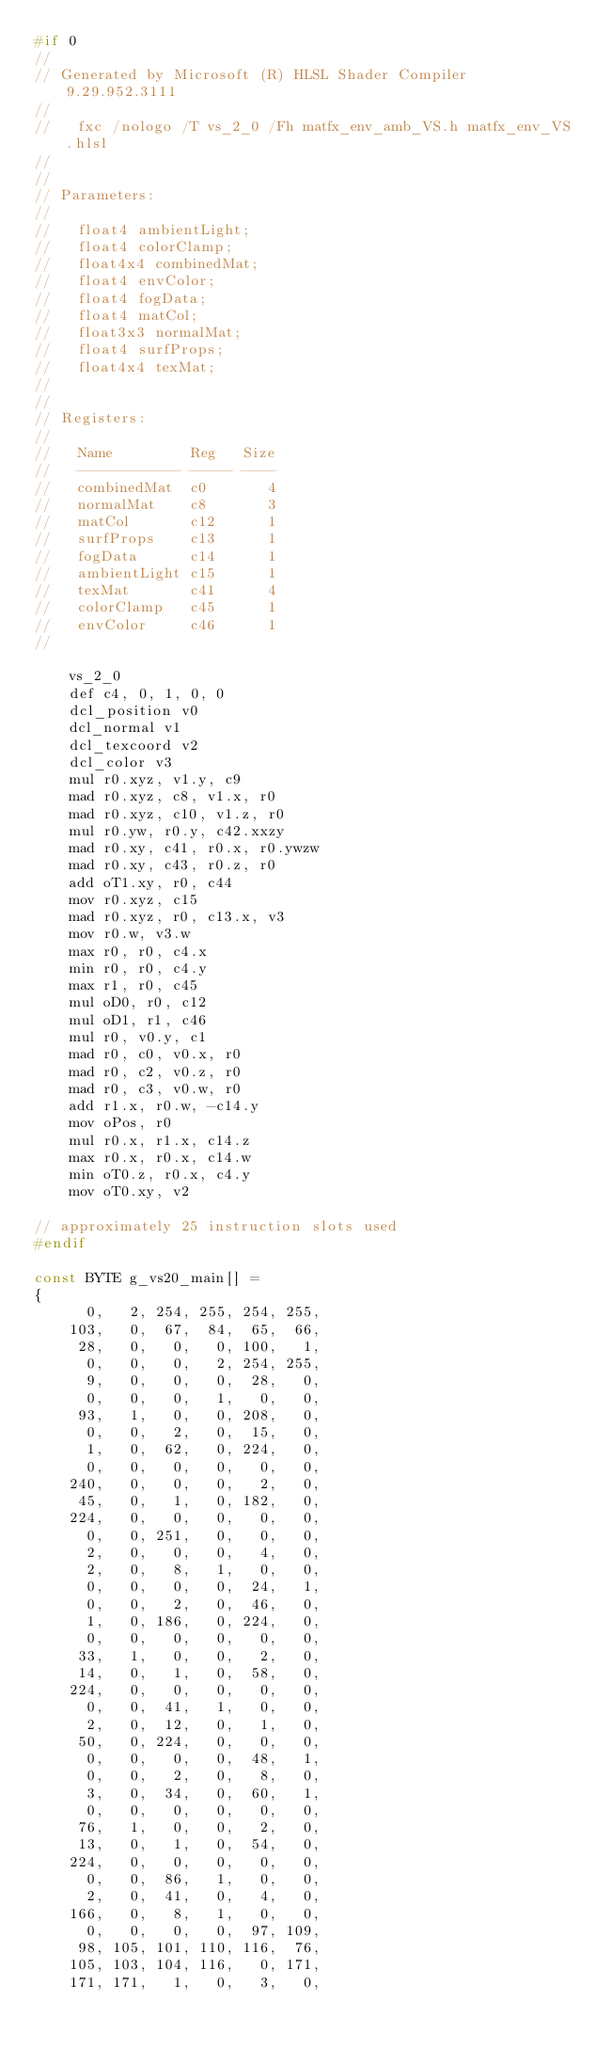Convert code to text. <code><loc_0><loc_0><loc_500><loc_500><_C_>#if 0
//
// Generated by Microsoft (R) HLSL Shader Compiler 9.29.952.3111
//
//   fxc /nologo /T vs_2_0 /Fh matfx_env_amb_VS.h matfx_env_VS.hlsl
//
//
// Parameters:
//
//   float4 ambientLight;
//   float4 colorClamp;
//   float4x4 combinedMat;
//   float4 envColor;
//   float4 fogData;
//   float4 matCol;
//   float3x3 normalMat;
//   float4 surfProps;
//   float4x4 texMat;
//
//
// Registers:
//
//   Name         Reg   Size
//   ------------ ----- ----
//   combinedMat  c0       4
//   normalMat    c8       3
//   matCol       c12      1
//   surfProps    c13      1
//   fogData      c14      1
//   ambientLight c15      1
//   texMat       c41      4
//   colorClamp   c45      1
//   envColor     c46      1
//

    vs_2_0
    def c4, 0, 1, 0, 0
    dcl_position v0
    dcl_normal v1
    dcl_texcoord v2
    dcl_color v3
    mul r0.xyz, v1.y, c9
    mad r0.xyz, c8, v1.x, r0
    mad r0.xyz, c10, v1.z, r0
    mul r0.yw, r0.y, c42.xxzy
    mad r0.xy, c41, r0.x, r0.ywzw
    mad r0.xy, c43, r0.z, r0
    add oT1.xy, r0, c44
    mov r0.xyz, c15
    mad r0.xyz, r0, c13.x, v3
    mov r0.w, v3.w
    max r0, r0, c4.x
    min r0, r0, c4.y
    max r1, r0, c45
    mul oD0, r0, c12
    mul oD1, r1, c46
    mul r0, v0.y, c1
    mad r0, c0, v0.x, r0
    mad r0, c2, v0.z, r0
    mad r0, c3, v0.w, r0
    add r1.x, r0.w, -c14.y
    mov oPos, r0
    mul r0.x, r1.x, c14.z
    max r0.x, r0.x, c14.w
    min oT0.z, r0.x, c4.y
    mov oT0.xy, v2

// approximately 25 instruction slots used
#endif

const BYTE g_vs20_main[] =
{
      0,   2, 254, 255, 254, 255, 
    103,   0,  67,  84,  65,  66, 
     28,   0,   0,   0, 100,   1, 
      0,   0,   0,   2, 254, 255, 
      9,   0,   0,   0,  28,   0, 
      0,   0,   0,   1,   0,   0, 
     93,   1,   0,   0, 208,   0, 
      0,   0,   2,   0,  15,   0, 
      1,   0,  62,   0, 224,   0, 
      0,   0,   0,   0,   0,   0, 
    240,   0,   0,   0,   2,   0, 
     45,   0,   1,   0, 182,   0, 
    224,   0,   0,   0,   0,   0, 
      0,   0, 251,   0,   0,   0, 
      2,   0,   0,   0,   4,   0, 
      2,   0,   8,   1,   0,   0, 
      0,   0,   0,   0,  24,   1, 
      0,   0,   2,   0,  46,   0, 
      1,   0, 186,   0, 224,   0, 
      0,   0,   0,   0,   0,   0, 
     33,   1,   0,   0,   2,   0, 
     14,   0,   1,   0,  58,   0, 
    224,   0,   0,   0,   0,   0, 
      0,   0,  41,   1,   0,   0, 
      2,   0,  12,   0,   1,   0, 
     50,   0, 224,   0,   0,   0, 
      0,   0,   0,   0,  48,   1, 
      0,   0,   2,   0,   8,   0, 
      3,   0,  34,   0,  60,   1, 
      0,   0,   0,   0,   0,   0, 
     76,   1,   0,   0,   2,   0, 
     13,   0,   1,   0,  54,   0, 
    224,   0,   0,   0,   0,   0, 
      0,   0,  86,   1,   0,   0, 
      2,   0,  41,   0,   4,   0, 
    166,   0,   8,   1,   0,   0, 
      0,   0,   0,   0,  97, 109, 
     98, 105, 101, 110, 116,  76, 
    105, 103, 104, 116,   0, 171, 
    171, 171,   1,   0,   3,   0, </code> 